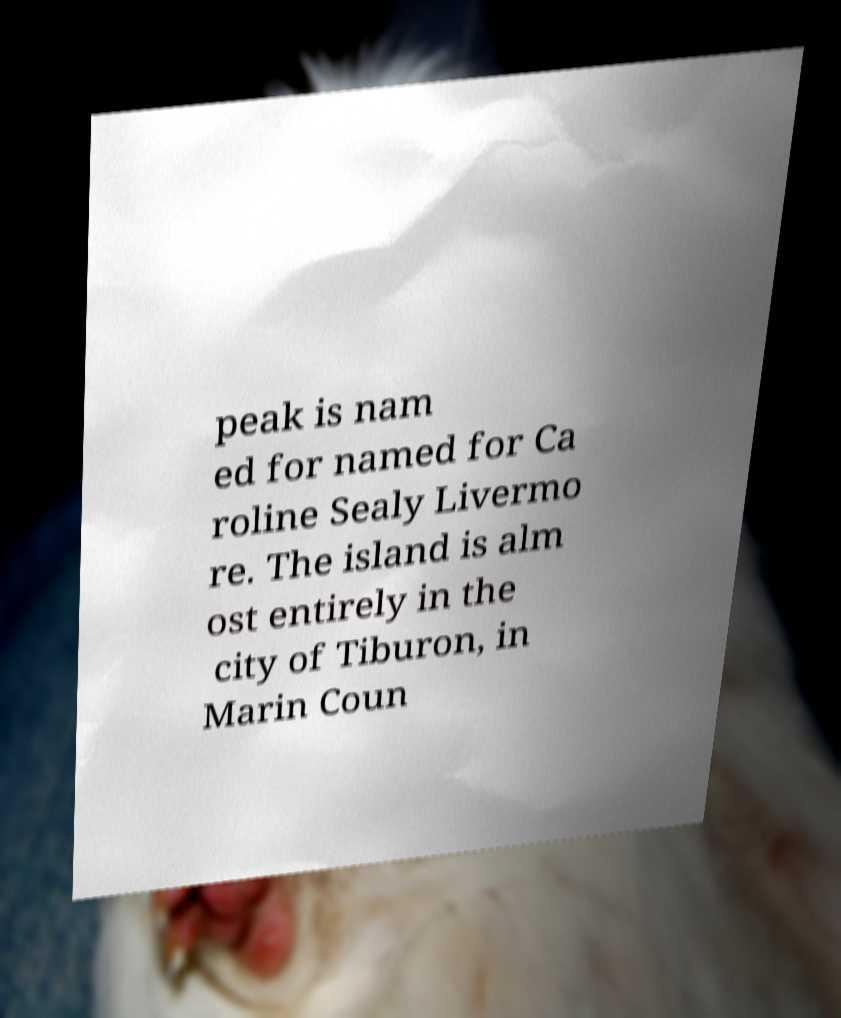Could you assist in decoding the text presented in this image and type it out clearly? peak is nam ed for named for Ca roline Sealy Livermo re. The island is alm ost entirely in the city of Tiburon, in Marin Coun 